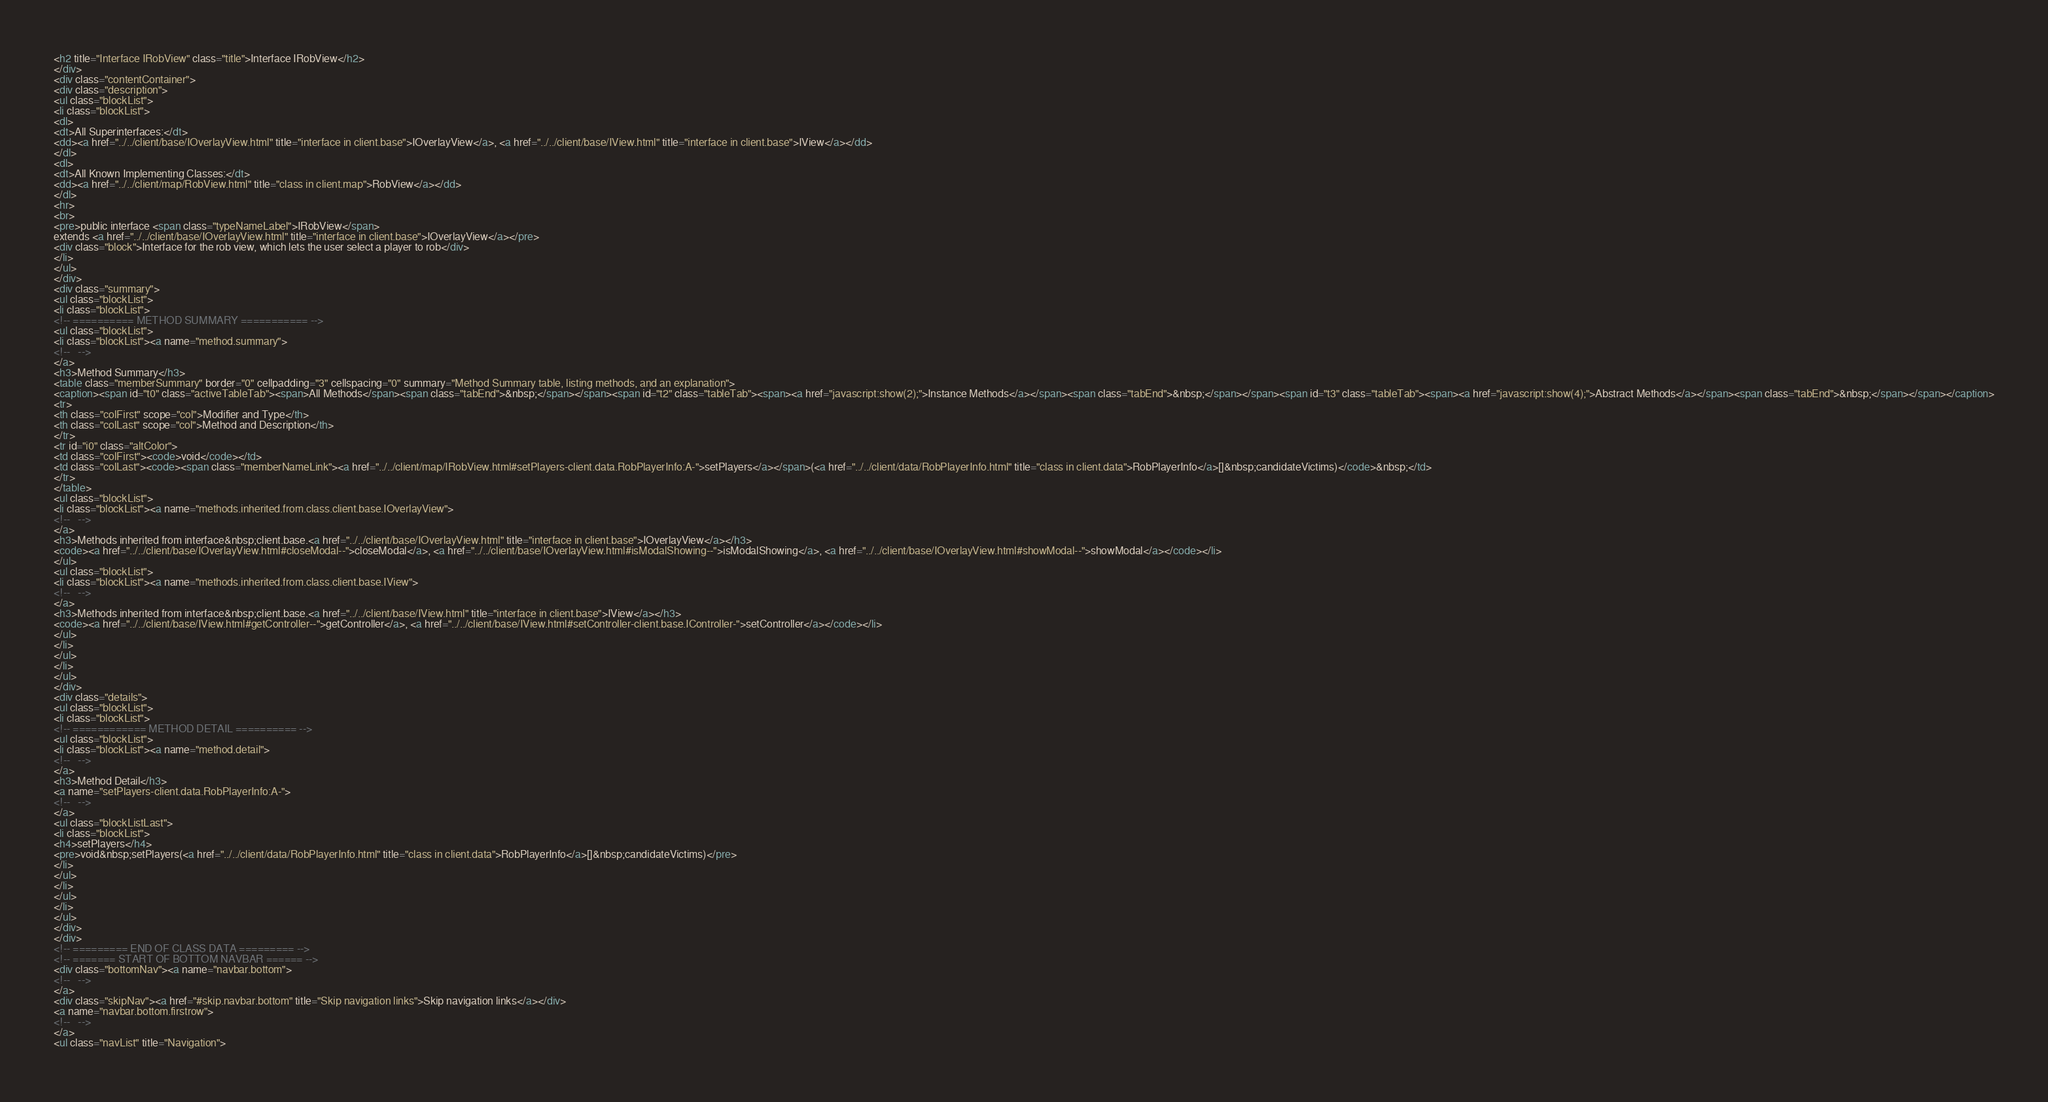Convert code to text. <code><loc_0><loc_0><loc_500><loc_500><_HTML_><h2 title="Interface IRobView" class="title">Interface IRobView</h2>
</div>
<div class="contentContainer">
<div class="description">
<ul class="blockList">
<li class="blockList">
<dl>
<dt>All Superinterfaces:</dt>
<dd><a href="../../client/base/IOverlayView.html" title="interface in client.base">IOverlayView</a>, <a href="../../client/base/IView.html" title="interface in client.base">IView</a></dd>
</dl>
<dl>
<dt>All Known Implementing Classes:</dt>
<dd><a href="../../client/map/RobView.html" title="class in client.map">RobView</a></dd>
</dl>
<hr>
<br>
<pre>public interface <span class="typeNameLabel">IRobView</span>
extends <a href="../../client/base/IOverlayView.html" title="interface in client.base">IOverlayView</a></pre>
<div class="block">Interface for the rob view, which lets the user select a player to rob</div>
</li>
</ul>
</div>
<div class="summary">
<ul class="blockList">
<li class="blockList">
<!-- ========== METHOD SUMMARY =========== -->
<ul class="blockList">
<li class="blockList"><a name="method.summary">
<!--   -->
</a>
<h3>Method Summary</h3>
<table class="memberSummary" border="0" cellpadding="3" cellspacing="0" summary="Method Summary table, listing methods, and an explanation">
<caption><span id="t0" class="activeTableTab"><span>All Methods</span><span class="tabEnd">&nbsp;</span></span><span id="t2" class="tableTab"><span><a href="javascript:show(2);">Instance Methods</a></span><span class="tabEnd">&nbsp;</span></span><span id="t3" class="tableTab"><span><a href="javascript:show(4);">Abstract Methods</a></span><span class="tabEnd">&nbsp;</span></span></caption>
<tr>
<th class="colFirst" scope="col">Modifier and Type</th>
<th class="colLast" scope="col">Method and Description</th>
</tr>
<tr id="i0" class="altColor">
<td class="colFirst"><code>void</code></td>
<td class="colLast"><code><span class="memberNameLink"><a href="../../client/map/IRobView.html#setPlayers-client.data.RobPlayerInfo:A-">setPlayers</a></span>(<a href="../../client/data/RobPlayerInfo.html" title="class in client.data">RobPlayerInfo</a>[]&nbsp;candidateVictims)</code>&nbsp;</td>
</tr>
</table>
<ul class="blockList">
<li class="blockList"><a name="methods.inherited.from.class.client.base.IOverlayView">
<!--   -->
</a>
<h3>Methods inherited from interface&nbsp;client.base.<a href="../../client/base/IOverlayView.html" title="interface in client.base">IOverlayView</a></h3>
<code><a href="../../client/base/IOverlayView.html#closeModal--">closeModal</a>, <a href="../../client/base/IOverlayView.html#isModalShowing--">isModalShowing</a>, <a href="../../client/base/IOverlayView.html#showModal--">showModal</a></code></li>
</ul>
<ul class="blockList">
<li class="blockList"><a name="methods.inherited.from.class.client.base.IView">
<!--   -->
</a>
<h3>Methods inherited from interface&nbsp;client.base.<a href="../../client/base/IView.html" title="interface in client.base">IView</a></h3>
<code><a href="../../client/base/IView.html#getController--">getController</a>, <a href="../../client/base/IView.html#setController-client.base.IController-">setController</a></code></li>
</ul>
</li>
</ul>
</li>
</ul>
</div>
<div class="details">
<ul class="blockList">
<li class="blockList">
<!-- ============ METHOD DETAIL ========== -->
<ul class="blockList">
<li class="blockList"><a name="method.detail">
<!--   -->
</a>
<h3>Method Detail</h3>
<a name="setPlayers-client.data.RobPlayerInfo:A-">
<!--   -->
</a>
<ul class="blockListLast">
<li class="blockList">
<h4>setPlayers</h4>
<pre>void&nbsp;setPlayers(<a href="../../client/data/RobPlayerInfo.html" title="class in client.data">RobPlayerInfo</a>[]&nbsp;candidateVictims)</pre>
</li>
</ul>
</li>
</ul>
</li>
</ul>
</div>
</div>
<!-- ========= END OF CLASS DATA ========= -->
<!-- ======= START OF BOTTOM NAVBAR ====== -->
<div class="bottomNav"><a name="navbar.bottom">
<!--   -->
</a>
<div class="skipNav"><a href="#skip.navbar.bottom" title="Skip navigation links">Skip navigation links</a></div>
<a name="navbar.bottom.firstrow">
<!--   -->
</a>
<ul class="navList" title="Navigation"></code> 